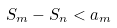Convert formula to latex. <formula><loc_0><loc_0><loc_500><loc_500>S _ { m } - S _ { n } < a _ { m }</formula> 